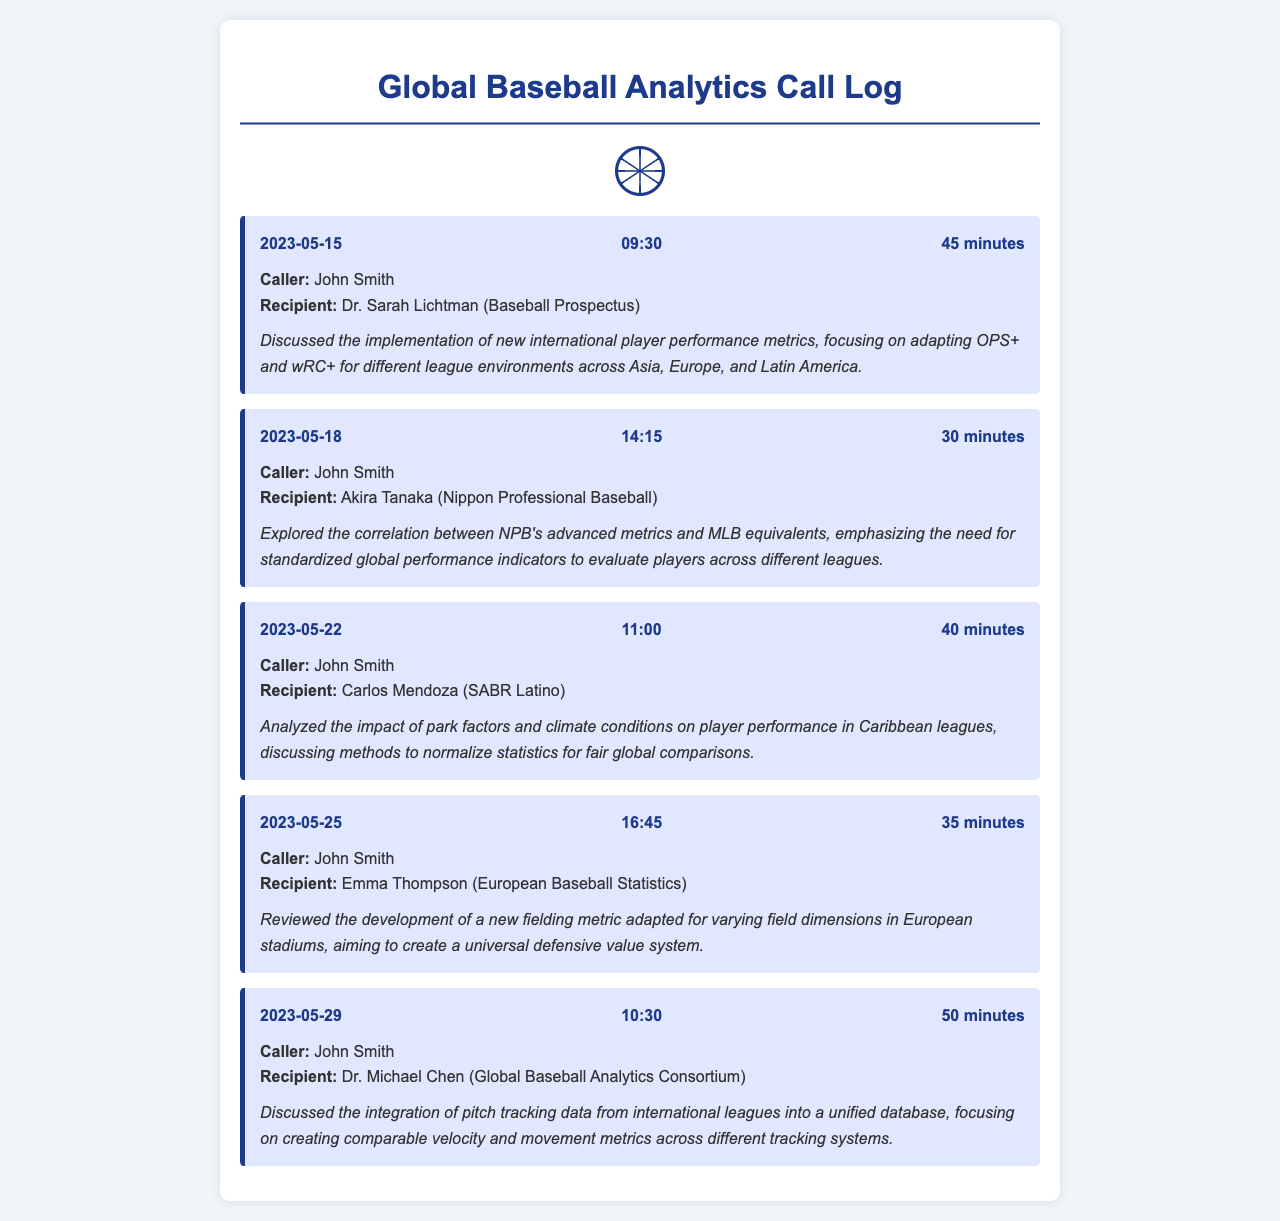What did John Smith discuss with Dr. Sarah Lichtman? The call summary mentions that John Smith discussed the implementation of new international player performance metrics.
Answer: International player performance metrics Which metric did John Smith focus on during his call with Akira Tanaka? The call summary indicates that John Smith emphasized the need for standardized global performance indicators.
Answer: Standardized global performance indicators On what date did John Smith call Carlos Mendoza? The call header shows that the call occurred on May 22, 2023.
Answer: May 22, 2023 How long was the call with Emma Thompson? The call header states that the call's duration was 35 minutes.
Answer: 35 minutes What international league's metrics were discussed in the call with Dr. Michael Chen? The call summary refers to the integration of pitch tracking data from international leagues.
Answer: International leagues Which aspect of performance did John Smith analyze with Carlos Mendoza? The call summary notes the impact of park factors and climate conditions on player performance.
Answer: Park factors and climate conditions Who were the participants in the call on May 25, 2023? The call header lists John Smith and Emma Thompson as participants.
Answer: John Smith and Emma Thompson What is the focus of the new fielding metric reviewed by John Smith? The call summary indicates that the new fielding metric is adapted for varying field dimensions in European stadiums.
Answer: Varying field dimensions in European stadiums 